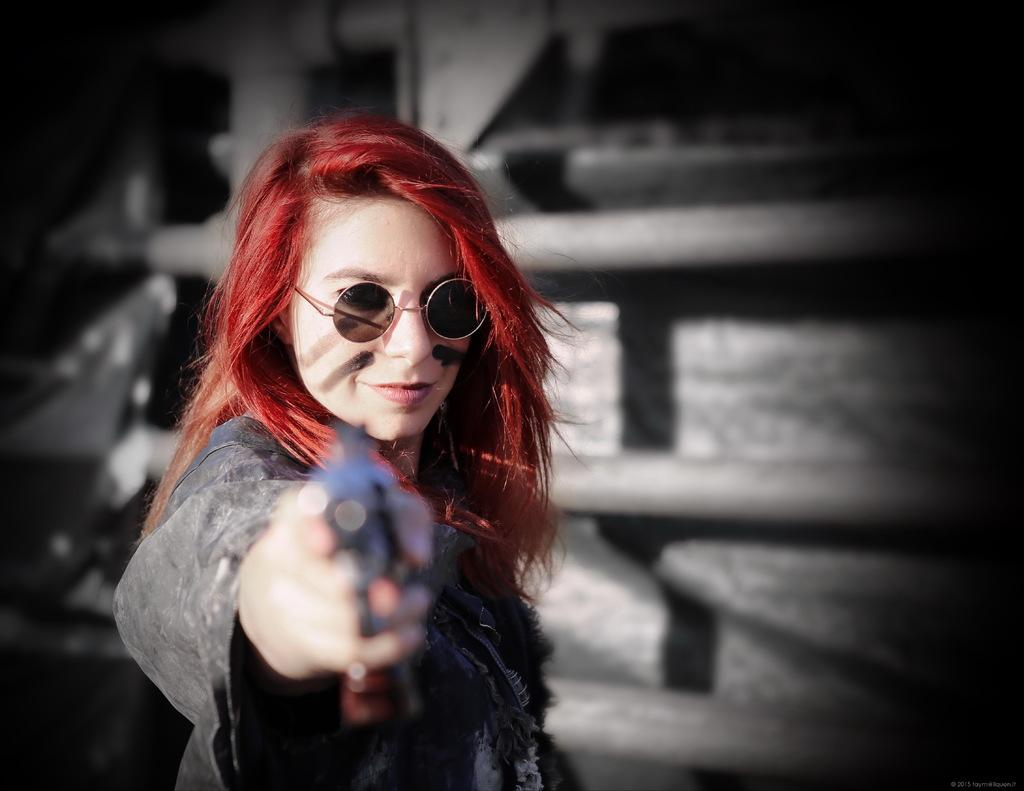Who is the main subject in the picture? There is a woman in the picture. What is the woman doing in the image? The woman is standing. What accessory is the woman wearing in the image? The woman is wearing sunglasses. What object is the woman holding in her hand? The woman is holding a gun in her hand. What expression does the woman have on her face? The woman has a smile on her face. What color are the woman's toenails in the image? There is no information about the woman's toenails in the image, so we cannot determine their color. 